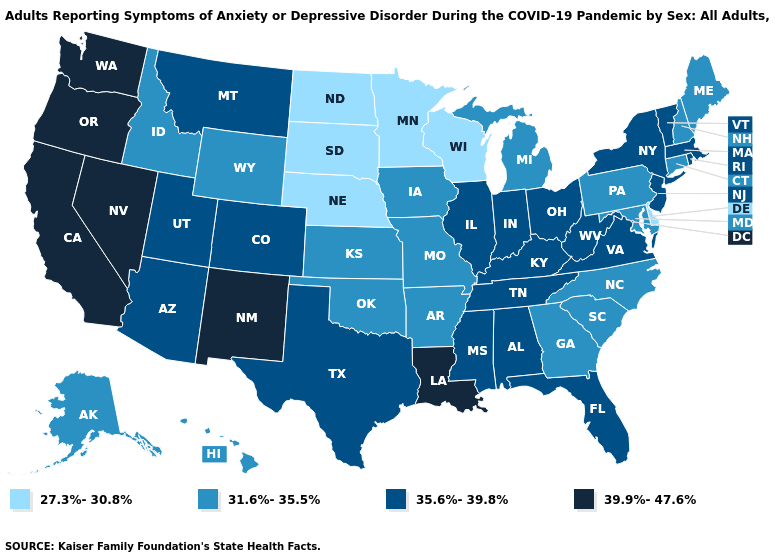Name the states that have a value in the range 39.9%-47.6%?
Short answer required. California, Louisiana, Nevada, New Mexico, Oregon, Washington. Does Louisiana have the lowest value in the USA?
Write a very short answer. No. Name the states that have a value in the range 35.6%-39.8%?
Quick response, please. Alabama, Arizona, Colorado, Florida, Illinois, Indiana, Kentucky, Massachusetts, Mississippi, Montana, New Jersey, New York, Ohio, Rhode Island, Tennessee, Texas, Utah, Vermont, Virginia, West Virginia. Among the states that border Connecticut , which have the lowest value?
Short answer required. Massachusetts, New York, Rhode Island. Is the legend a continuous bar?
Give a very brief answer. No. What is the lowest value in the USA?
Answer briefly. 27.3%-30.8%. Does the first symbol in the legend represent the smallest category?
Answer briefly. Yes. Does Delaware have the lowest value in the South?
Be succinct. Yes. What is the lowest value in the USA?
Give a very brief answer. 27.3%-30.8%. Which states hav the highest value in the West?
Keep it brief. California, Nevada, New Mexico, Oregon, Washington. What is the lowest value in the Northeast?
Give a very brief answer. 31.6%-35.5%. What is the lowest value in the USA?
Concise answer only. 27.3%-30.8%. Which states hav the highest value in the West?
Keep it brief. California, Nevada, New Mexico, Oregon, Washington. Which states have the lowest value in the West?
Quick response, please. Alaska, Hawaii, Idaho, Wyoming. Among the states that border North Carolina , which have the lowest value?
Give a very brief answer. Georgia, South Carolina. 